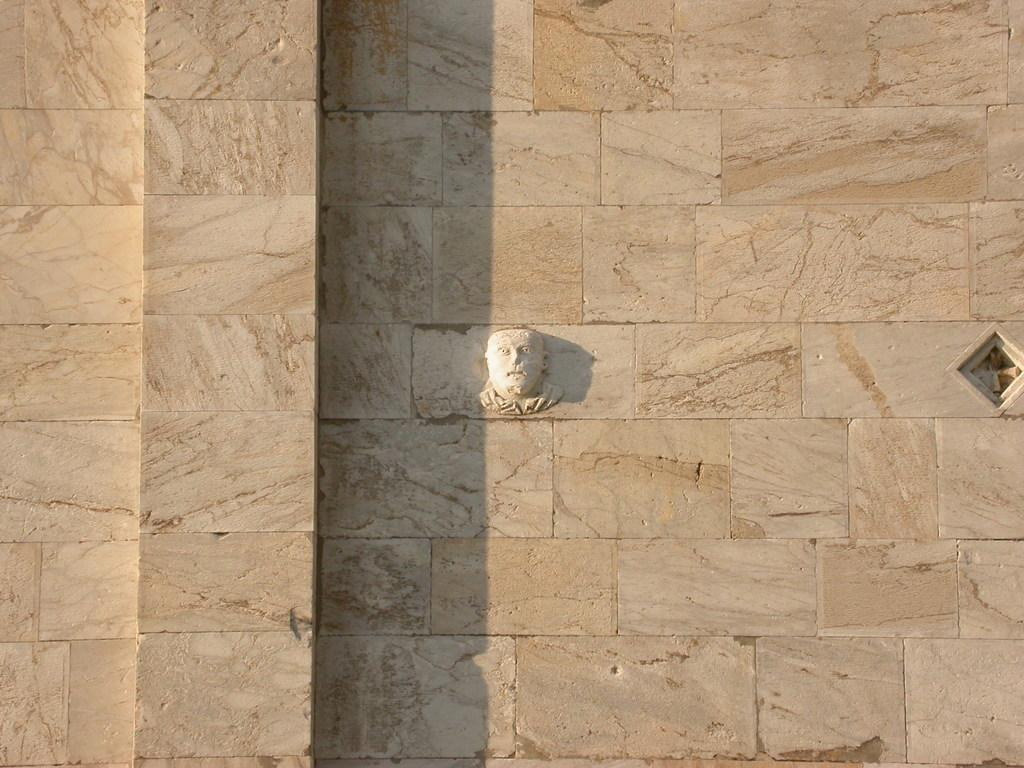What is present on the wall in the image? There is a sculpture on the wall in the image. Can you describe the wall in the image? There is a wall in the image, and it has a sculpture on it. What is visible on the right side of the image? There is a small window on the right side of the image. How many people are in the crowd gathered around the sculpture in the image? There is no crowd present in the image; it only features a wall with a sculpture on it and a small window on the right side. 